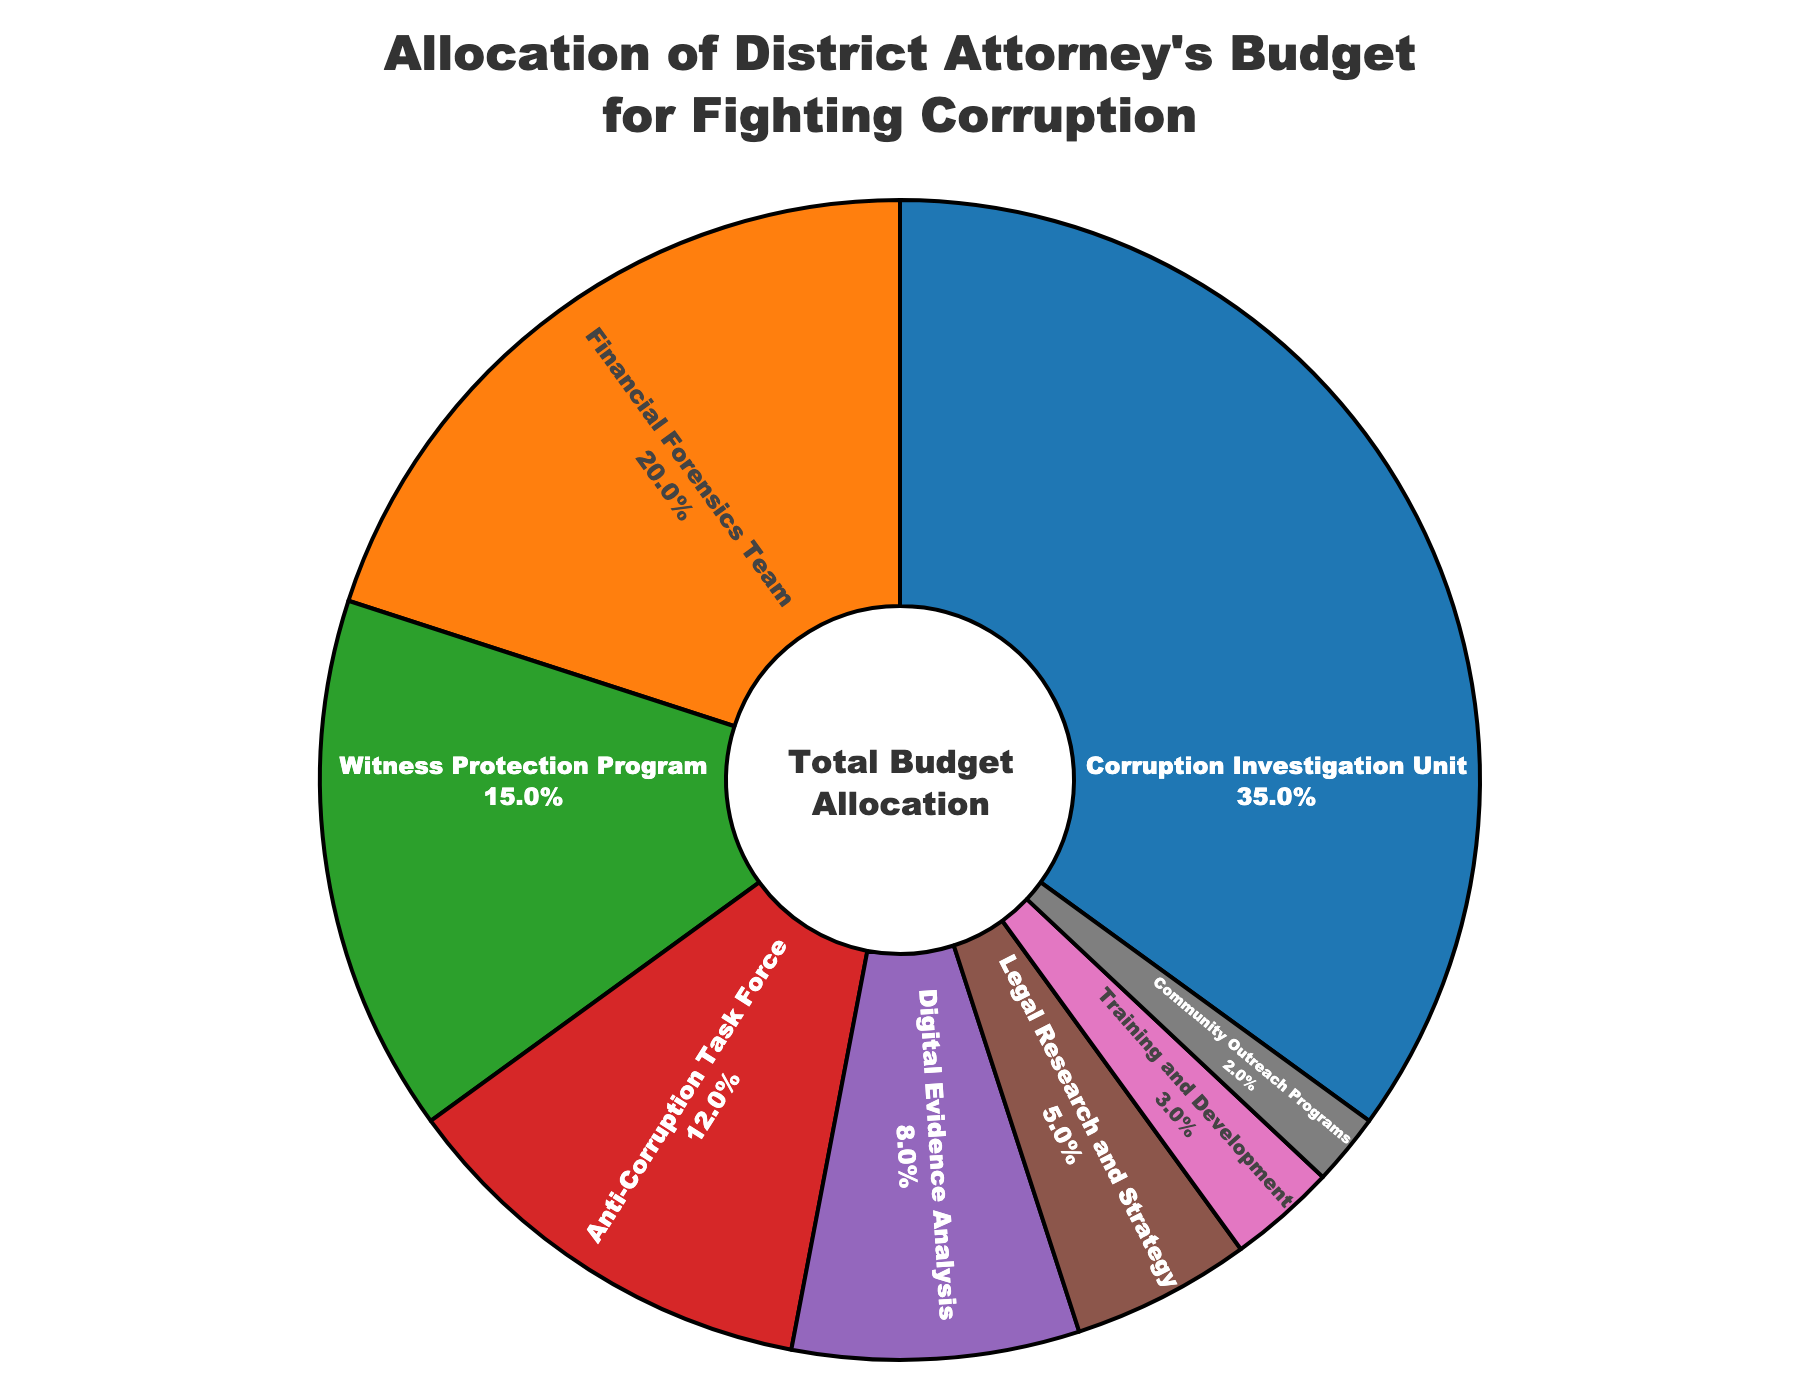What percentage of the district attorney’s budget is allocated to the Corruption Investigation Unit? The Corruption Investigation Unit has a segment in the pie chart which represents 35% of the total budget allocation.
Answer: 35% Which category has the lowest budget allocation? The smallest segment on the pie chart represents 'Community Outreach Programs', which is allocated 2% of the budget.
Answer: Community Outreach Programs What is the combined budget allocation for the Financial Forensics Team and the Digital Evidence Analysis? The Financial Forensics Team has 20% and the Digital Evidence Analysis has 8%. Summing these gives 20% + 8% = 28%.
Answer: 28% Which category receives more funding: Anti-Corruption Task Force or Witness Protection Program? The pie chart shows that the Witness Protection Program receives 15% while the Anti-Corruption Task Force receives 12%, so the Witness Protection Program receives more funding.
Answer: Witness Protection Program What is the difference in budget allocation between Legal Research and Strategy and Training and Development? Legal Research and Strategy is allocated 5% and Training and Development is allocated 3%. The difference is 5% - 3% = 2%.
Answer: 2% How much more percentage is allocated to the Corruption Investigation Unit compared to the Anti-Corruption Task Force? The Corruption Investigation Unit is allocated 35% and the Anti-Corruption Task Force is allocated 12%. The difference is 35% - 12% = 23%.
Answer: 23% If the budget for Community Outreach Programs was doubled, what percentage would it be? The current budget for Community Outreach Programs is 2%. If doubled, it would be 2% * 2 = 4%.
Answer: 4% Which categories have a budget allocation lower than 10%? The pie chart shows Digital Evidence Analysis with 8%, Legal Research and Strategy with 5%, Training and Development with 3%, and Community Outreach Programs with 2%, all of which are under 10%.
Answer: Digital Evidence Analysis, Legal Research and Strategy, Training and Development, Community Outreach Programs What is the total percentage allocated to witness-related categories? Witness Protection Program is allocated 15%. This is the only category directly related to witnesses.
Answer: 15% 